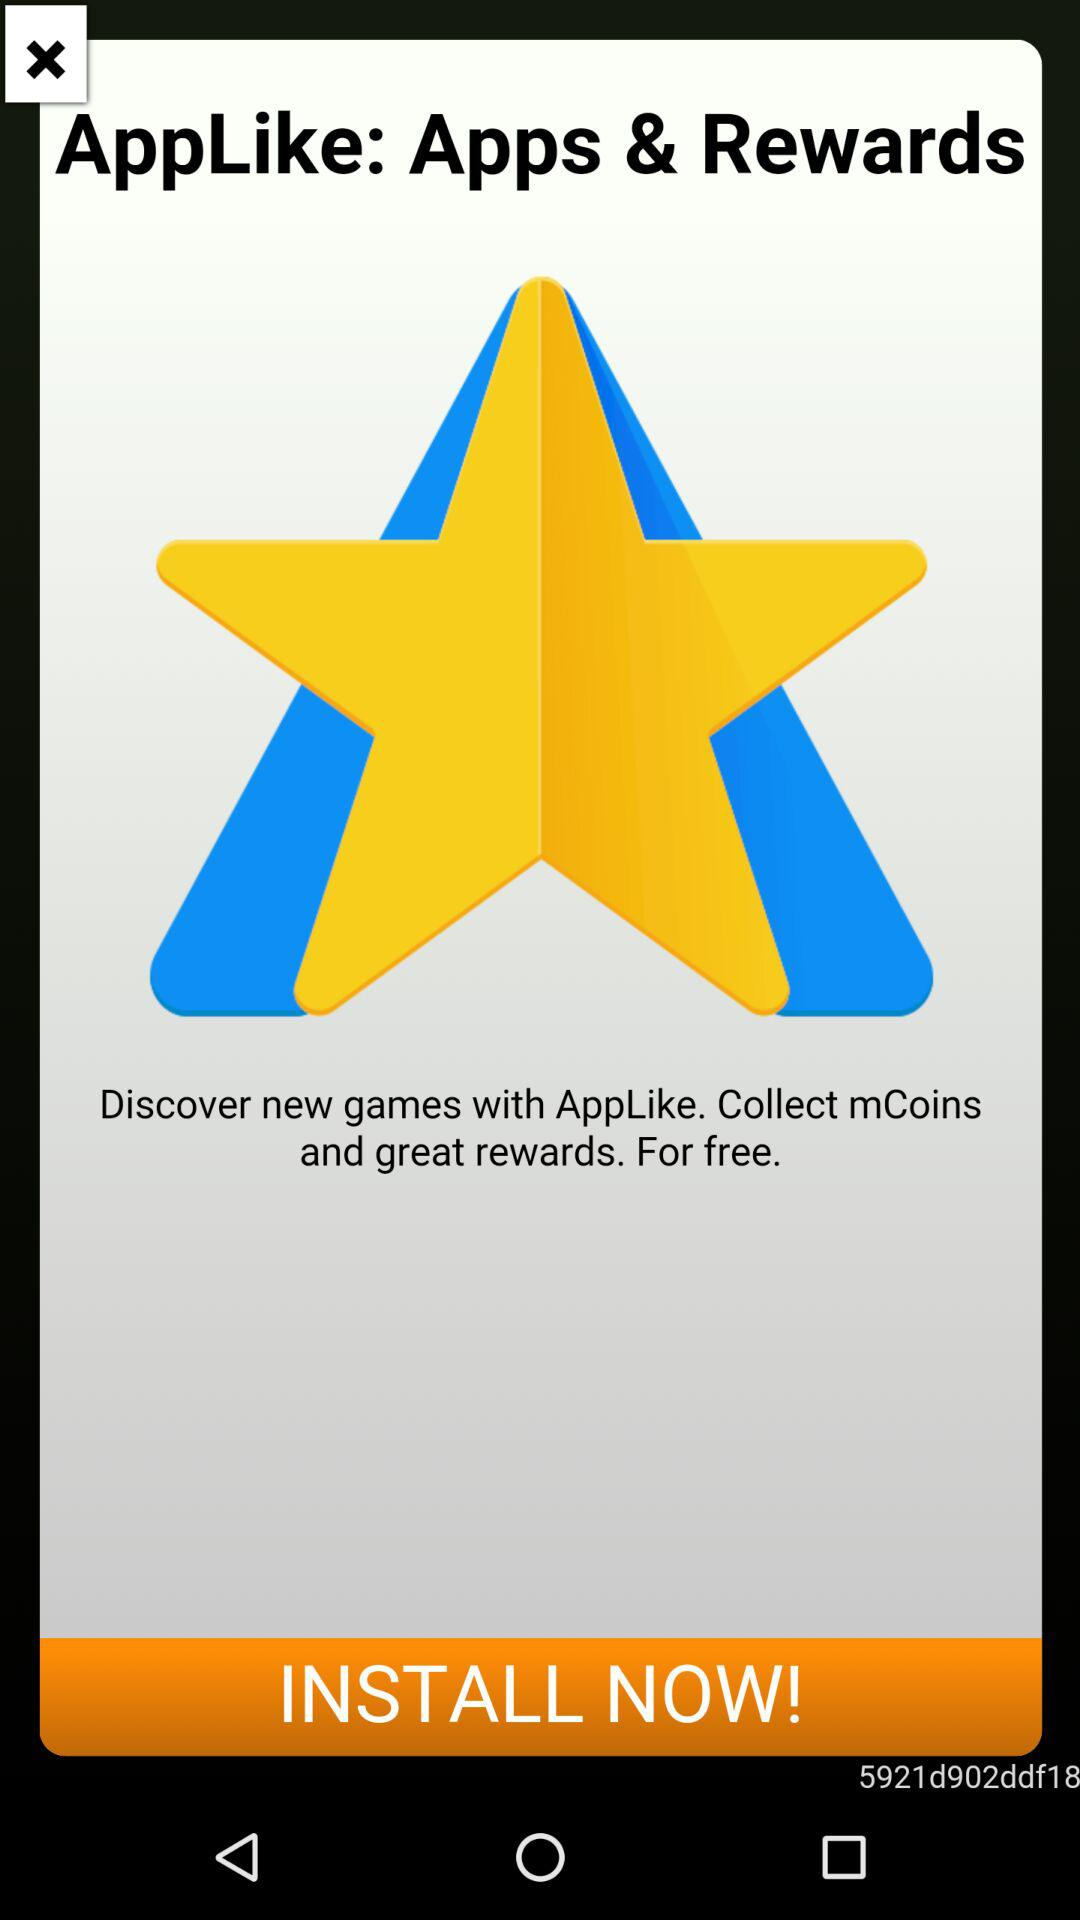What is the name of the application? The name of the application is "AppLike". 